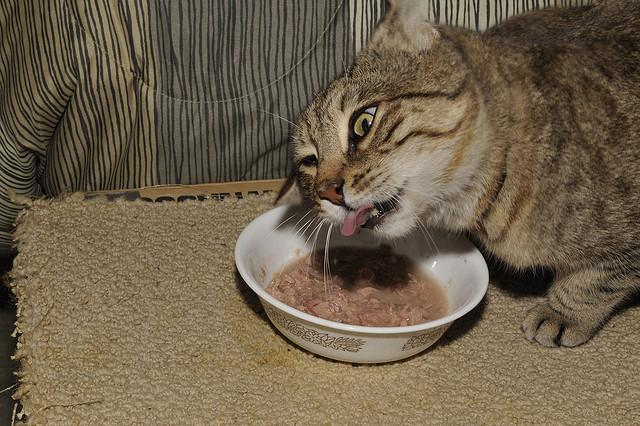How many cats are in the scene?
Give a very brief answer. 1. How many of the cat's ears are visible?
Give a very brief answer. 1. How many cats can be seen?
Give a very brief answer. 1. How many bowls can you see?
Give a very brief answer. 1. How many people are wearing helmets?
Give a very brief answer. 0. 